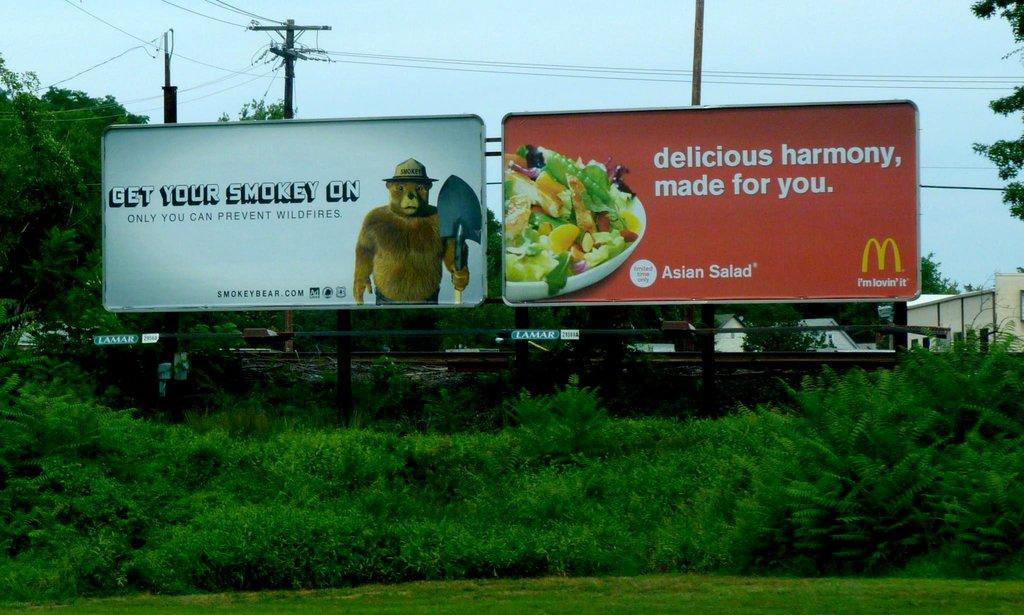<image>
Share a concise interpretation of the image provided. Smokey the Bear advertises to prevent forest fires next to a McDonalds billboard. 